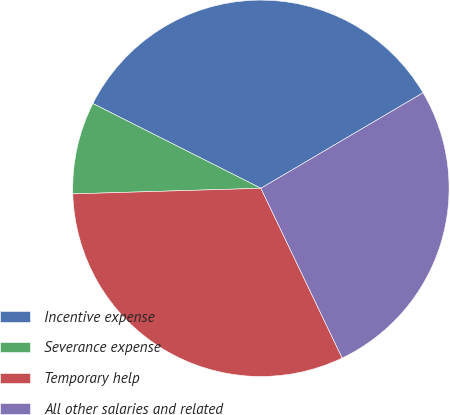Convert chart. <chart><loc_0><loc_0><loc_500><loc_500><pie_chart><fcel>Incentive expense<fcel>Severance expense<fcel>Temporary help<fcel>All other salaries and related<nl><fcel>34.09%<fcel>7.91%<fcel>31.63%<fcel>26.36%<nl></chart> 